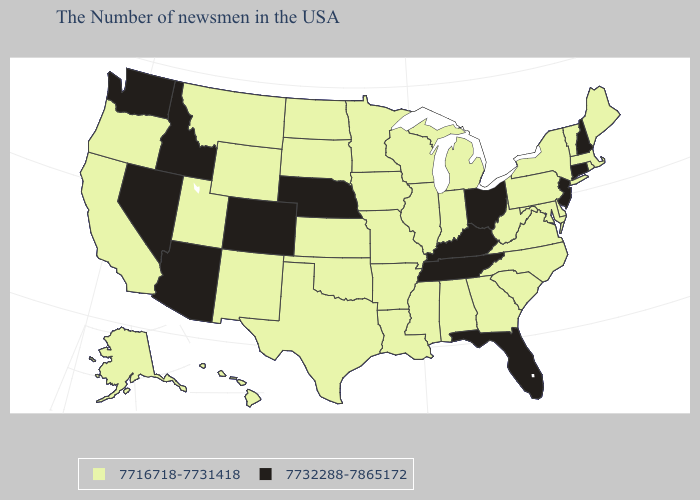What is the lowest value in states that border Minnesota?
Short answer required. 7716718-7731418. Name the states that have a value in the range 7732288-7865172?
Write a very short answer. New Hampshire, Connecticut, New Jersey, Ohio, Florida, Kentucky, Tennessee, Nebraska, Colorado, Arizona, Idaho, Nevada, Washington. What is the value of Alabama?
Concise answer only. 7716718-7731418. Name the states that have a value in the range 7716718-7731418?
Quick response, please. Maine, Massachusetts, Rhode Island, Vermont, New York, Delaware, Maryland, Pennsylvania, Virginia, North Carolina, South Carolina, West Virginia, Georgia, Michigan, Indiana, Alabama, Wisconsin, Illinois, Mississippi, Louisiana, Missouri, Arkansas, Minnesota, Iowa, Kansas, Oklahoma, Texas, South Dakota, North Dakota, Wyoming, New Mexico, Utah, Montana, California, Oregon, Alaska, Hawaii. What is the value of South Dakota?
Quick response, please. 7716718-7731418. Does New Jersey have the lowest value in the Northeast?
Quick response, please. No. Name the states that have a value in the range 7732288-7865172?
Answer briefly. New Hampshire, Connecticut, New Jersey, Ohio, Florida, Kentucky, Tennessee, Nebraska, Colorado, Arizona, Idaho, Nevada, Washington. What is the value of Arizona?
Answer briefly. 7732288-7865172. Name the states that have a value in the range 7732288-7865172?
Be succinct. New Hampshire, Connecticut, New Jersey, Ohio, Florida, Kentucky, Tennessee, Nebraska, Colorado, Arizona, Idaho, Nevada, Washington. What is the lowest value in the West?
Keep it brief. 7716718-7731418. What is the lowest value in the USA?
Short answer required. 7716718-7731418. Name the states that have a value in the range 7716718-7731418?
Answer briefly. Maine, Massachusetts, Rhode Island, Vermont, New York, Delaware, Maryland, Pennsylvania, Virginia, North Carolina, South Carolina, West Virginia, Georgia, Michigan, Indiana, Alabama, Wisconsin, Illinois, Mississippi, Louisiana, Missouri, Arkansas, Minnesota, Iowa, Kansas, Oklahoma, Texas, South Dakota, North Dakota, Wyoming, New Mexico, Utah, Montana, California, Oregon, Alaska, Hawaii. What is the value of Colorado?
Concise answer only. 7732288-7865172. Does Wisconsin have the highest value in the MidWest?
Write a very short answer. No. Name the states that have a value in the range 7732288-7865172?
Concise answer only. New Hampshire, Connecticut, New Jersey, Ohio, Florida, Kentucky, Tennessee, Nebraska, Colorado, Arizona, Idaho, Nevada, Washington. 